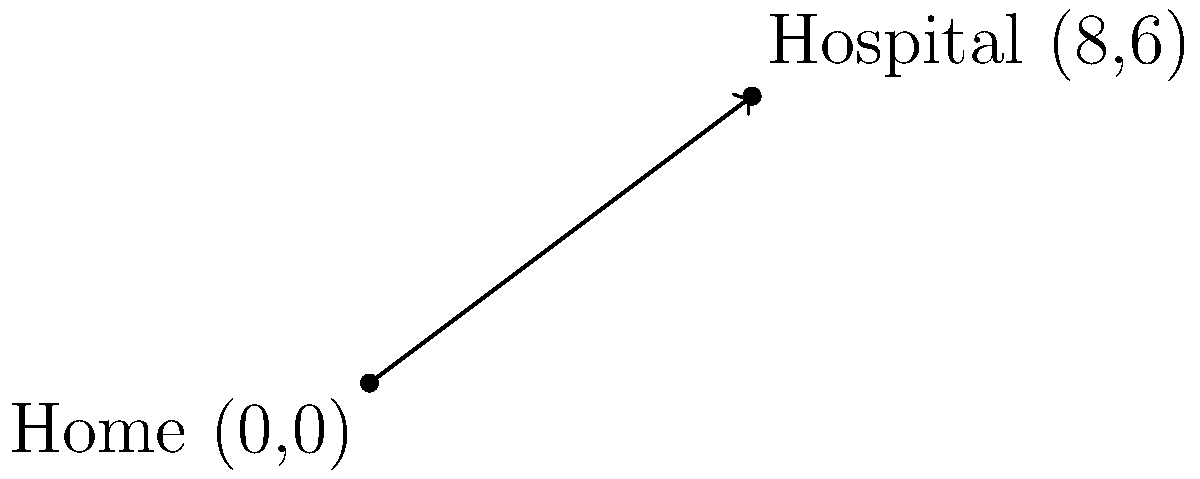You're planning your route from your home to Wellstar North Fulton Hospital. Given that your home is located at the origin (0,0) and the hospital is at coordinates (8,6), what is the slope of the line representing the direct route from your home to the hospital? To find the slope of the line, we can use the slope formula:

$$ \text{slope} = m = \frac{y_2 - y_1}{x_2 - x_1} $$

Where $(x_1, y_1)$ is the starting point (home) and $(x_2, y_2)$ is the ending point (hospital).

Step 1: Identify the coordinates
- Home: $(x_1, y_1) = (0, 0)$
- Hospital: $(x_2, y_2) = (8, 6)$

Step 2: Plug the values into the slope formula
$$ m = \frac{y_2 - y_1}{x_2 - x_1} = \frac{6 - 0}{8 - 0} = \frac{6}{8} $$

Step 3: Simplify the fraction
$$ m = \frac{6}{8} = \frac{3}{4} = 0.75 $$

Therefore, the slope of the line representing the direct route from your home to the hospital is $\frac{3}{4}$ or 0.75.
Answer: $\frac{3}{4}$ 